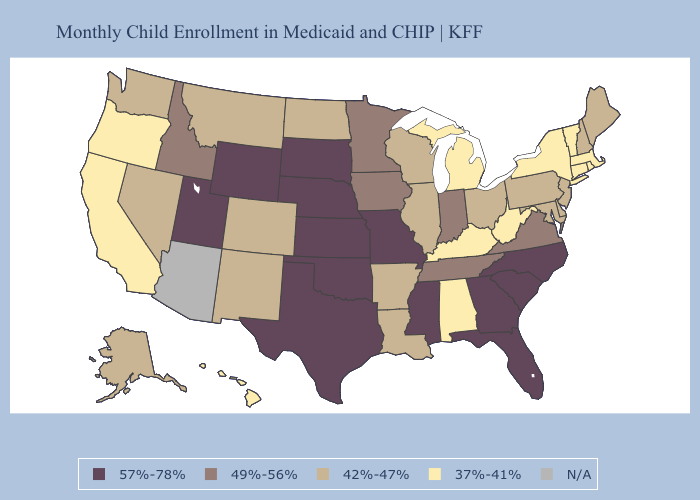Does Pennsylvania have the highest value in the Northeast?
Write a very short answer. Yes. What is the lowest value in the USA?
Write a very short answer. 37%-41%. What is the value of Missouri?
Write a very short answer. 57%-78%. What is the highest value in the South ?
Short answer required. 57%-78%. Name the states that have a value in the range 49%-56%?
Write a very short answer. Idaho, Indiana, Iowa, Minnesota, Tennessee, Virginia. Name the states that have a value in the range 37%-41%?
Answer briefly. Alabama, California, Connecticut, Hawaii, Kentucky, Massachusetts, Michigan, New York, Oregon, Rhode Island, Vermont, West Virginia. Name the states that have a value in the range 57%-78%?
Quick response, please. Florida, Georgia, Kansas, Mississippi, Missouri, Nebraska, North Carolina, Oklahoma, South Carolina, South Dakota, Texas, Utah, Wyoming. Which states hav the highest value in the South?
Write a very short answer. Florida, Georgia, Mississippi, North Carolina, Oklahoma, South Carolina, Texas. What is the value of Arizona?
Answer briefly. N/A. What is the value of Idaho?
Give a very brief answer. 49%-56%. Name the states that have a value in the range 49%-56%?
Concise answer only. Idaho, Indiana, Iowa, Minnesota, Tennessee, Virginia. What is the lowest value in the USA?
Give a very brief answer. 37%-41%. Name the states that have a value in the range 42%-47%?
Write a very short answer. Alaska, Arkansas, Colorado, Delaware, Illinois, Louisiana, Maine, Maryland, Montana, Nevada, New Hampshire, New Jersey, New Mexico, North Dakota, Ohio, Pennsylvania, Washington, Wisconsin. What is the value of Kansas?
Short answer required. 57%-78%. What is the value of Florida?
Answer briefly. 57%-78%. 